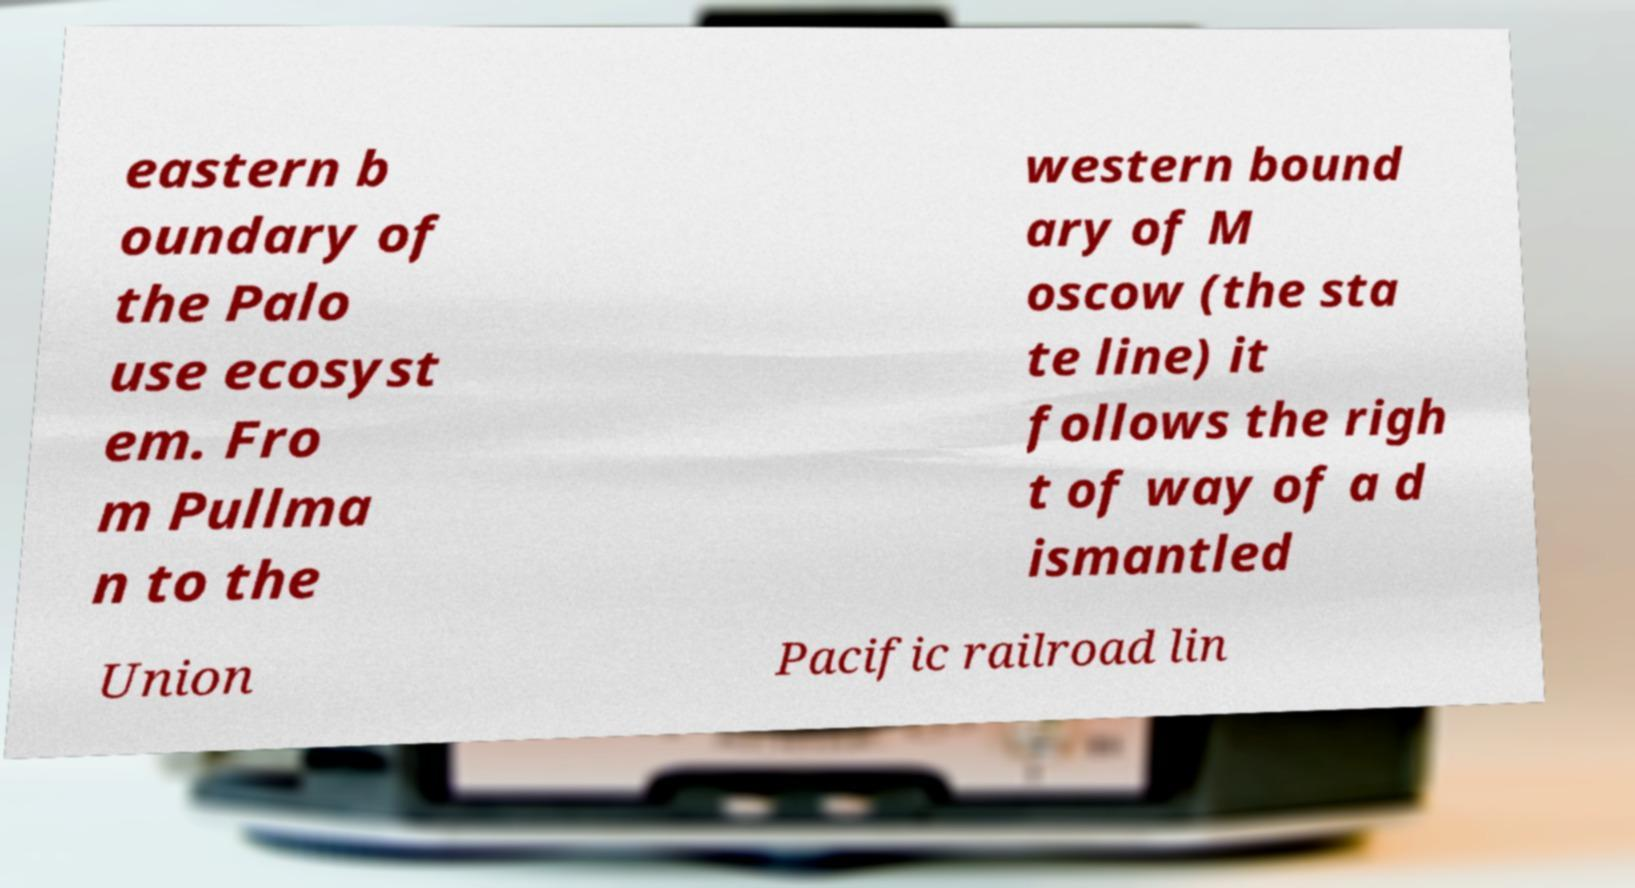Please read and relay the text visible in this image. What does it say? eastern b oundary of the Palo use ecosyst em. Fro m Pullma n to the western bound ary of M oscow (the sta te line) it follows the righ t of way of a d ismantled Union Pacific railroad lin 